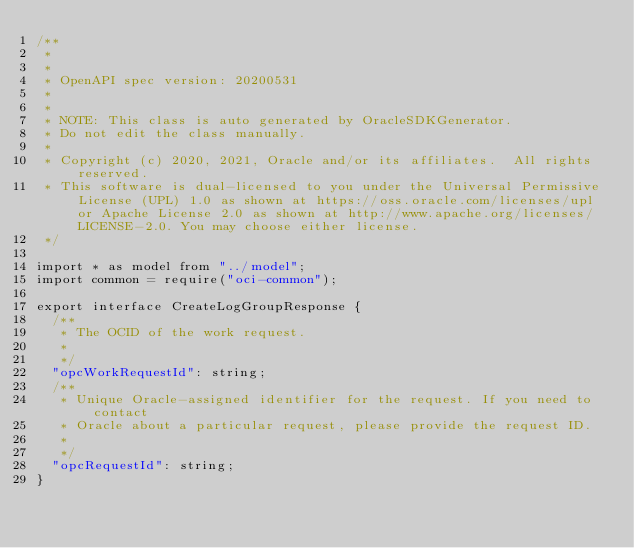Convert code to text. <code><loc_0><loc_0><loc_500><loc_500><_TypeScript_>/**
 *
 *
 * OpenAPI spec version: 20200531
 *
 *
 * NOTE: This class is auto generated by OracleSDKGenerator.
 * Do not edit the class manually.
 *
 * Copyright (c) 2020, 2021, Oracle and/or its affiliates.  All rights reserved.
 * This software is dual-licensed to you under the Universal Permissive License (UPL) 1.0 as shown at https://oss.oracle.com/licenses/upl or Apache License 2.0 as shown at http://www.apache.org/licenses/LICENSE-2.0. You may choose either license.
 */

import * as model from "../model";
import common = require("oci-common");

export interface CreateLogGroupResponse {
  /**
   * The OCID of the work request.
   *
   */
  "opcWorkRequestId": string;
  /**
   * Unique Oracle-assigned identifier for the request. If you need to contact
   * Oracle about a particular request, please provide the request ID.
   *
   */
  "opcRequestId": string;
}
</code> 